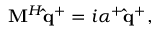<formula> <loc_0><loc_0><loc_500><loc_500>M ^ { H } \hat { q } ^ { + } = i \alpha ^ { + } \hat { q } ^ { + } ,</formula> 